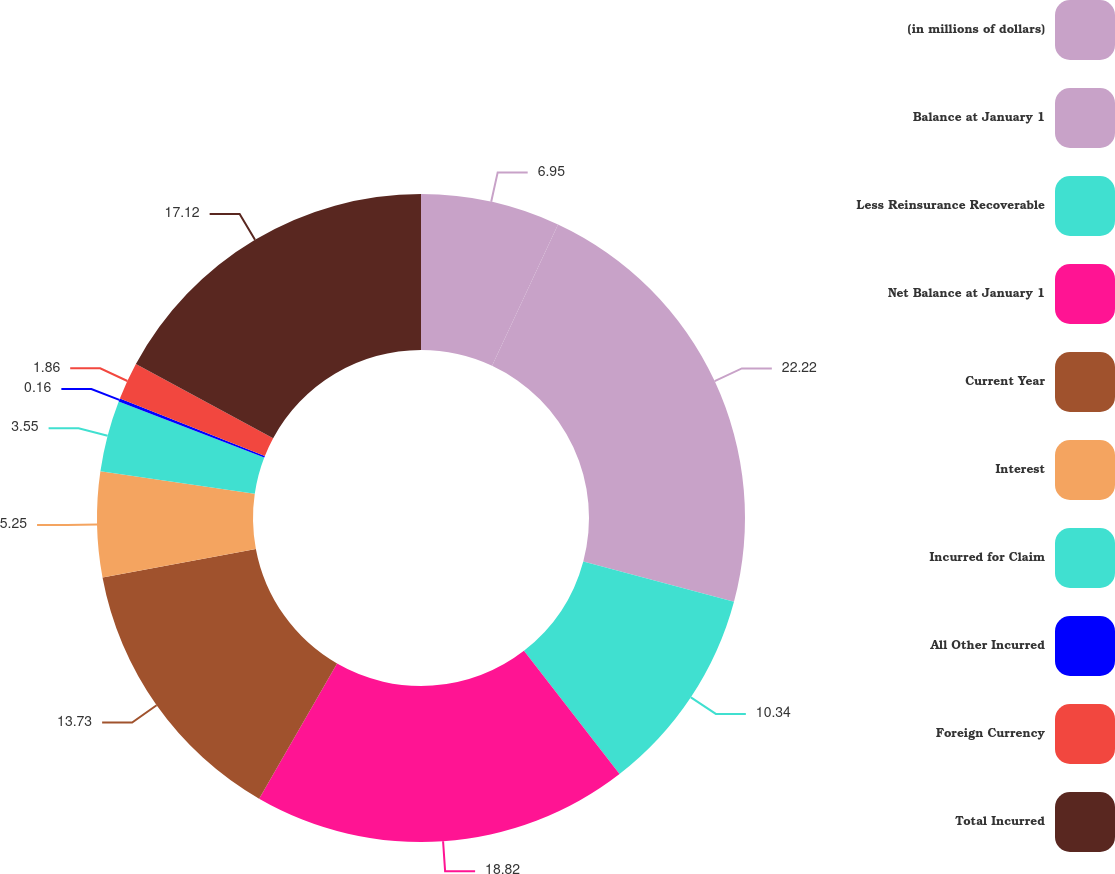Convert chart to OTSL. <chart><loc_0><loc_0><loc_500><loc_500><pie_chart><fcel>(in millions of dollars)<fcel>Balance at January 1<fcel>Less Reinsurance Recoverable<fcel>Net Balance at January 1<fcel>Current Year<fcel>Interest<fcel>Incurred for Claim<fcel>All Other Incurred<fcel>Foreign Currency<fcel>Total Incurred<nl><fcel>6.95%<fcel>22.21%<fcel>10.34%<fcel>18.82%<fcel>13.73%<fcel>5.25%<fcel>3.55%<fcel>0.16%<fcel>1.86%<fcel>17.12%<nl></chart> 